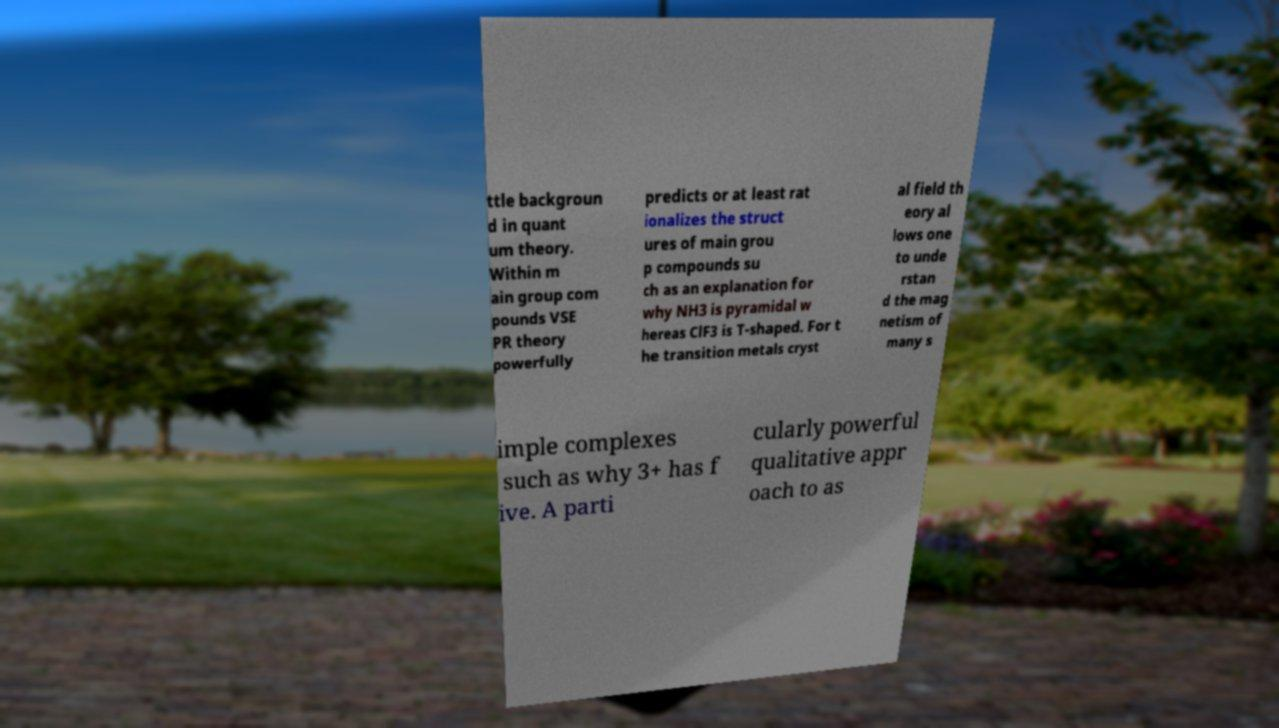Can you read and provide the text displayed in the image?This photo seems to have some interesting text. Can you extract and type it out for me? ttle backgroun d in quant um theory. Within m ain group com pounds VSE PR theory powerfully predicts or at least rat ionalizes the struct ures of main grou p compounds su ch as an explanation for why NH3 is pyramidal w hereas ClF3 is T-shaped. For t he transition metals cryst al field th eory al lows one to unde rstan d the mag netism of many s imple complexes such as why 3+ has f ive. A parti cularly powerful qualitative appr oach to as 